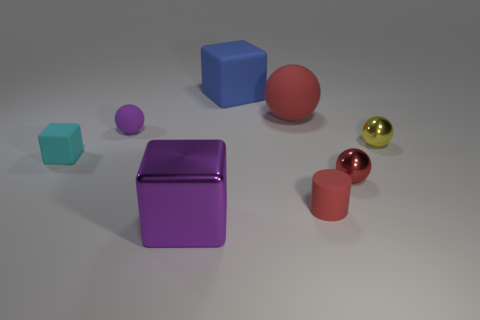How many yellow metallic things are there?
Keep it short and to the point. 1. Are there any red objects of the same size as the blue cube?
Your response must be concise. Yes. Is the material of the cylinder the same as the big cube that is in front of the purple rubber thing?
Your response must be concise. No. What is the material of the tiny ball to the left of the big shiny thing?
Keep it short and to the point. Rubber. How big is the red matte ball?
Keep it short and to the point. Large. There is a red ball that is behind the tiny red sphere; is its size the same as the cube right of the big purple cube?
Provide a succinct answer. Yes. What size is the red rubber object that is the same shape as the small yellow metal object?
Ensure brevity in your answer.  Large. Do the red shiny sphere and the matte cube that is to the right of the purple block have the same size?
Keep it short and to the point. No. There is a ball left of the big blue thing; is there a rubber ball right of it?
Ensure brevity in your answer.  Yes. There is a small cyan matte thing in front of the tiny yellow sphere; what is its shape?
Ensure brevity in your answer.  Cube. 